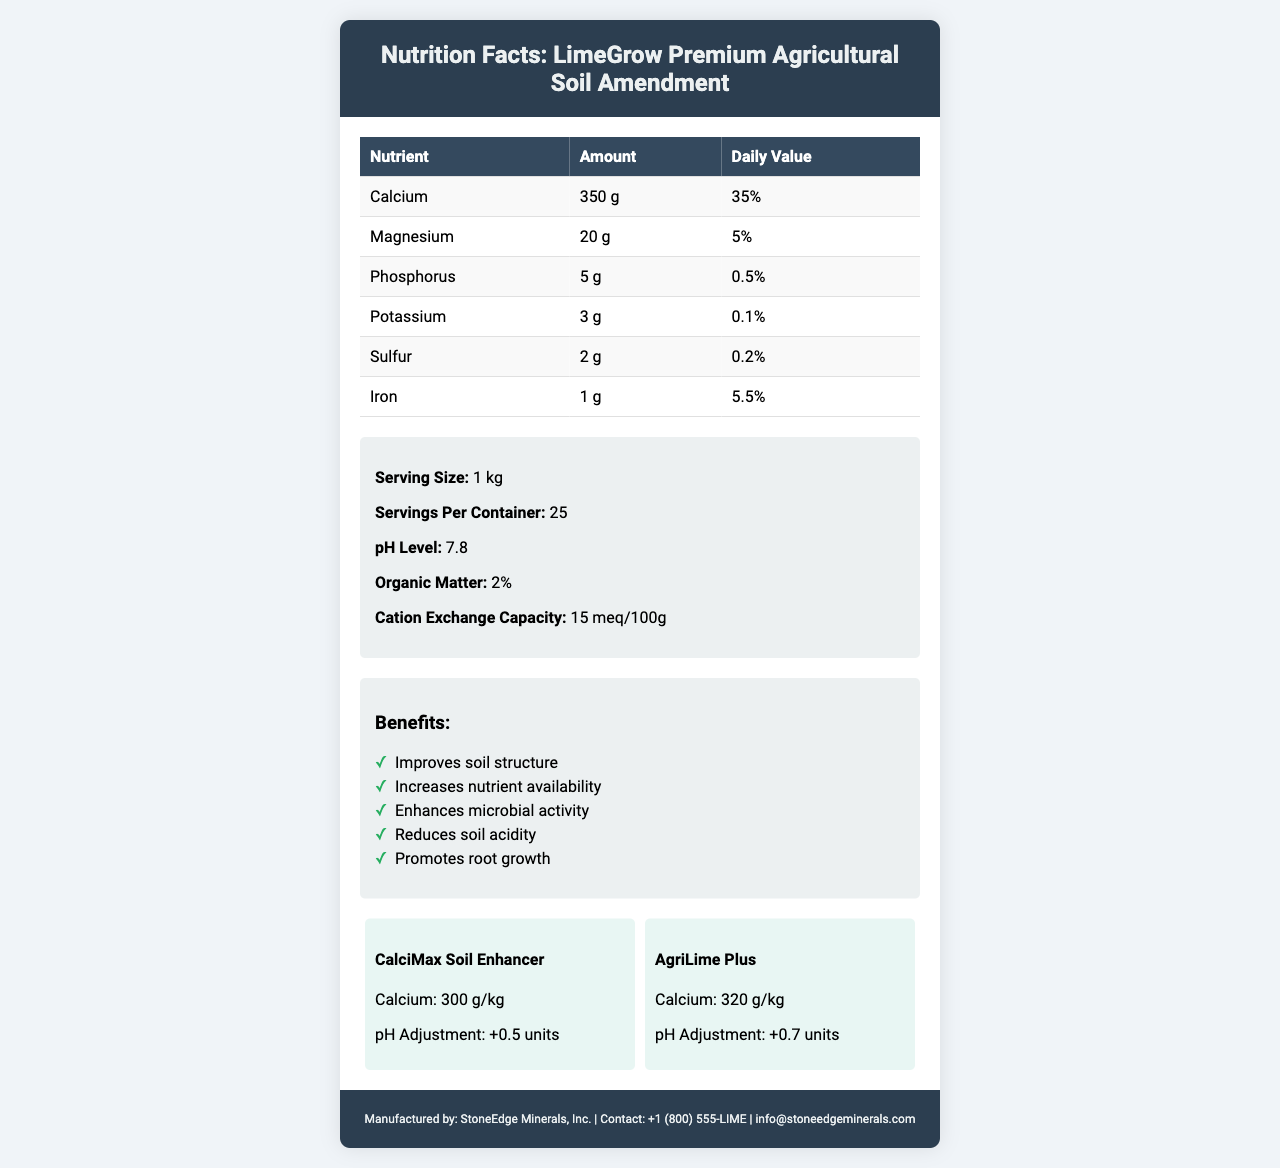what is the serving size of LimeGrow Premium Agricultural Soil Amendment? The serving size is listed as "1 kg" in the document.
Answer: 1 kg how many servings are there per container of LimeGrow Premium Agricultural Soil Amendment? The document states there are 25 servings per container.
Answer: 25 what is the pH level of LimeGrow Premium Agricultural Soil Amendment? The pH level is given as 7.8 in the additional information section.
Answer: 7.8 what is the organic matter content in LimeGrow Premium Agricultural Soil Amendment? The organic matter content is listed as "2%".
Answer: 2% which two competitors are compared in the document? The competitor comparison section mentions CalciMax Soil Enhancer and AgriLime Plus.
Answer: CalciMax Soil Enhancer and AgriLime Plus What amount of calcium is present in LimeGrow Premium Agricultural Soil Amendment per serving? The document states that each serving contains 350 g of calcium.
Answer: 350 g what is the cation exchange capacity of LimeGrow Premium Agricultural Soil Amendment? The cation exchange capacity is listed as "15 meq/100g".
Answer: 15 meq/100g what is the carbon footprint of LimeGrow Premium Agricultural Soil Amendment? The document mentions that the carbon footprint is 0.2 kg CO2e per kg of product.
Answer: 0.2 kg CO2e per kg of product how long is the shelf life of LimeGrow Premium Agricultural Soil Amendment? The shelf life is noted as 5 years from the date of manufacture.
Answer: 5 years from date of manufacture which certification has LimeGrow Premium Agricultural Soil Amendment received? A. USDA Organic B. California Certified Organic Farmers (CCOF) C. Both D. None The document states that the product has received both USDA Organic and California Certified Organic Farmers (CCOF) certifications.
Answer: C what is a suitable crop for LimeGrow Premium Agricultural Soil Amendment? A. Citrus B. Corn C. Apple D. Barley Corn is listed as a suitable crop for this product.
Answer: B which nutrient has the highest daily value percentage in LimeGrow Premium Agricultural Soil Amendment? A. Calcium B. Magnesium C. Phosphorus D. Iron Calcium has the highest daily value percentage of 35%.
Answer: A is LimeGrow Premium Agricultural Soil Amendment suitable for wheat? The document lists wheat as one of the suitable crops.
Answer: Yes describe the main benefits provided by LimeGrow Premium Agricultural Soil Amendment in one sentence. The benefits section highlights these five key advantages in bulleted form.
Answer: It improves soil structure, increases nutrient availability, enhances microbial activity, reduces soil acidity, and promotes root growth. what are the contact details for the manufacturer? These details are available in the footer section of the document.
Answer: Phone: +1 (800) 555-LIME; Email: info@stoneedgeminerals.com what is the water usage reduction benefit of LimeGrow Premium Agricultural Soil Amendment? The environmental impact section mentions this specific benefit.
Answer: Reduces irrigation needs by up to 15% What is the total amount of magnesium in 3 kg of LimeGrow Premium Agricultural Soil Amendment? One kg contains 20 g of magnesium, so 3 kg would contain 60 g.
Answer: 60 g What is the calcium content of CalciMax Soil Enhancer compared to LimeGrow Premium Agricultural Soil Amendment? The competitor comparison shows CalciMax Soil Enhancer with 300 g/kg calcium while LimeGrow has 350 g/kg.
Answer: 300 g/kg compared to 350 g/kg What is the email contact for StoneEdge Minerals, Inc.? This information is located in the footer of the document.
Answer: info@stoneedgeminerals.com what is the application rate for high usage of LimeGrow Premium Agricultural Soil Amendment? The document lists the high application rate as 6 tons/acre.
Answer: 6 tons/acre What is the manufacturer of LimeGrow Premium Agricultural Soil Amendment? The footer section mentions that the product is manufactured by StoneEdge Minerals, Inc.
Answer: StoneEdge Minerals, Inc. What is the effect of LimeGrow Premium Agricultural Soil Amendment on soil biodiversity? The environmental impact section states that the product supports soil microorganism diversity.
Answer: Supports soil microorganism diversity what amount of iron is present in LimeGrow Premium Agricultural Soil Amendment? The nutrient content table lists 1 g of iron.
Answer: 1 g What is the storage instruction for LimeGrow Premium Agricultural Soil Amendment? The storage instructions section provides these details.
Answer: Store in a cool, dry place. Keep container sealed when not in use. What is the exact percentage of daily value for Phosphorus in LimeGrow Premium Agricultural Soil Amendment? The nutrient content table lists the daily value for phosphorus as 0.5%.
Answer: 0.5% Can you determine the specific date of manufacture for the product? The document does not provide the exact date of manufacture, thus this information is not available.
Answer: Not enough information 